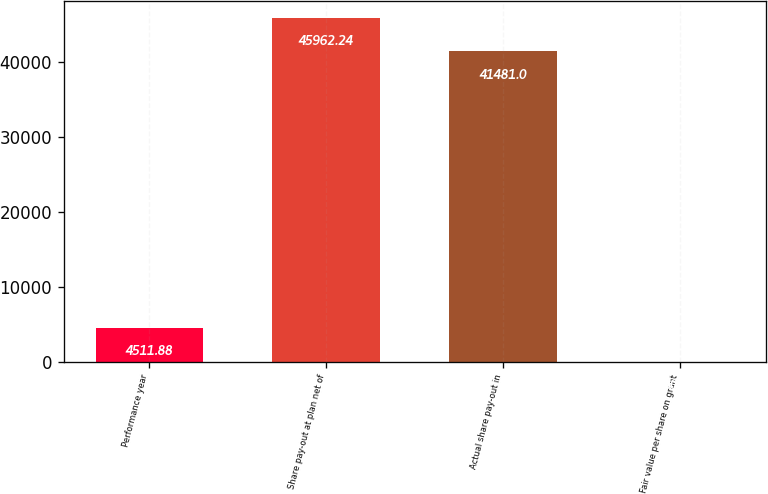Convert chart. <chart><loc_0><loc_0><loc_500><loc_500><bar_chart><fcel>Performance year<fcel>Share pay-out at plan net of<fcel>Actual share pay-out in<fcel>Fair value per share on grant<nl><fcel>4511.88<fcel>45962.2<fcel>41481<fcel>30.64<nl></chart> 